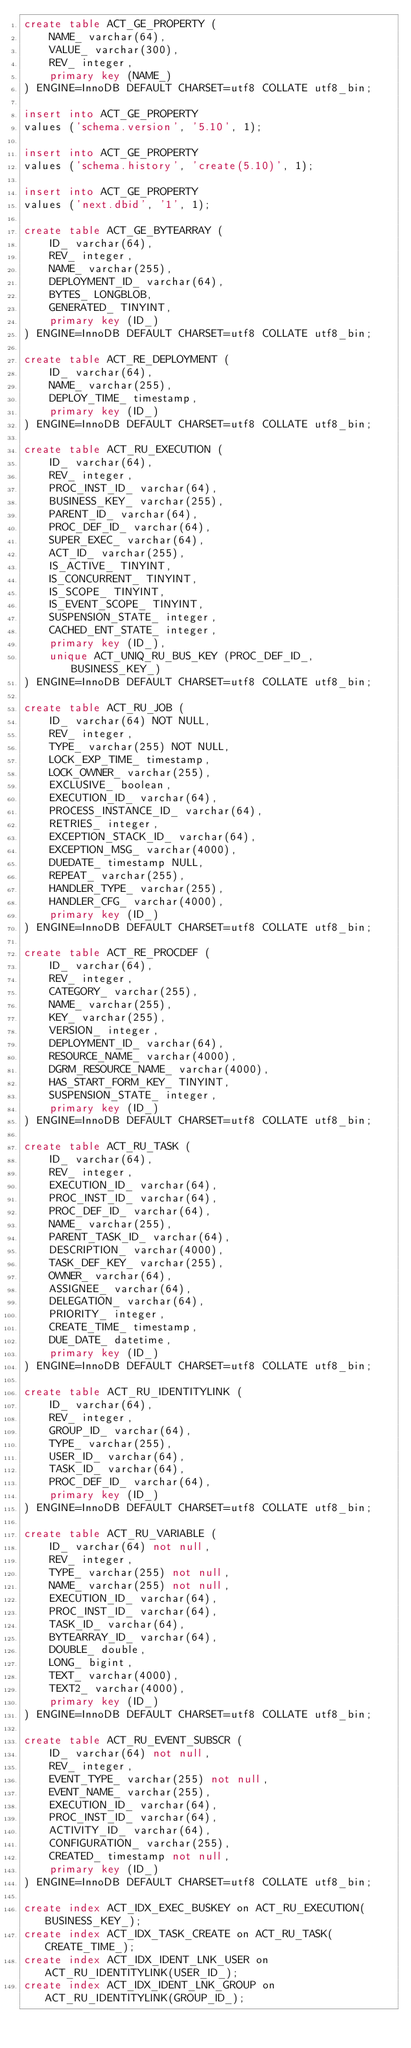Convert code to text. <code><loc_0><loc_0><loc_500><loc_500><_SQL_>create table ACT_GE_PROPERTY (
    NAME_ varchar(64),
    VALUE_ varchar(300),
    REV_ integer,
    primary key (NAME_)
) ENGINE=InnoDB DEFAULT CHARSET=utf8 COLLATE utf8_bin;

insert into ACT_GE_PROPERTY
values ('schema.version', '5.10', 1);

insert into ACT_GE_PROPERTY
values ('schema.history', 'create(5.10)', 1);

insert into ACT_GE_PROPERTY
values ('next.dbid', '1', 1);

create table ACT_GE_BYTEARRAY (
    ID_ varchar(64),
    REV_ integer,
    NAME_ varchar(255),
    DEPLOYMENT_ID_ varchar(64),
    BYTES_ LONGBLOB,
    GENERATED_ TINYINT,
    primary key (ID_)
) ENGINE=InnoDB DEFAULT CHARSET=utf8 COLLATE utf8_bin;

create table ACT_RE_DEPLOYMENT (
    ID_ varchar(64),
    NAME_ varchar(255),
    DEPLOY_TIME_ timestamp,
    primary key (ID_)
) ENGINE=InnoDB DEFAULT CHARSET=utf8 COLLATE utf8_bin;

create table ACT_RU_EXECUTION (
    ID_ varchar(64),
    REV_ integer,
    PROC_INST_ID_ varchar(64),
    BUSINESS_KEY_ varchar(255),
    PARENT_ID_ varchar(64),
    PROC_DEF_ID_ varchar(64),
    SUPER_EXEC_ varchar(64),
    ACT_ID_ varchar(255),
    IS_ACTIVE_ TINYINT,
    IS_CONCURRENT_ TINYINT,
    IS_SCOPE_ TINYINT,
    IS_EVENT_SCOPE_ TINYINT,
    SUSPENSION_STATE_ integer,
    CACHED_ENT_STATE_ integer,
    primary key (ID_),
    unique ACT_UNIQ_RU_BUS_KEY (PROC_DEF_ID_, BUSINESS_KEY_)
) ENGINE=InnoDB DEFAULT CHARSET=utf8 COLLATE utf8_bin;

create table ACT_RU_JOB (
    ID_ varchar(64) NOT NULL,
	  REV_ integer,
    TYPE_ varchar(255) NOT NULL,
    LOCK_EXP_TIME_ timestamp,
    LOCK_OWNER_ varchar(255),
    EXCLUSIVE_ boolean,
    EXECUTION_ID_ varchar(64),
    PROCESS_INSTANCE_ID_ varchar(64),
    RETRIES_ integer,
    EXCEPTION_STACK_ID_ varchar(64),
    EXCEPTION_MSG_ varchar(4000),
    DUEDATE_ timestamp NULL,
    REPEAT_ varchar(255),
    HANDLER_TYPE_ varchar(255),
    HANDLER_CFG_ varchar(4000),
    primary key (ID_)
) ENGINE=InnoDB DEFAULT CHARSET=utf8 COLLATE utf8_bin;

create table ACT_RE_PROCDEF (
    ID_ varchar(64),
    REV_ integer,
    CATEGORY_ varchar(255),
    NAME_ varchar(255),
    KEY_ varchar(255),
    VERSION_ integer,
    DEPLOYMENT_ID_ varchar(64),
    RESOURCE_NAME_ varchar(4000),
    DGRM_RESOURCE_NAME_ varchar(4000),
    HAS_START_FORM_KEY_ TINYINT,
    SUSPENSION_STATE_ integer,
    primary key (ID_)
) ENGINE=InnoDB DEFAULT CHARSET=utf8 COLLATE utf8_bin;

create table ACT_RU_TASK (
    ID_ varchar(64),
    REV_ integer,
    EXECUTION_ID_ varchar(64),
    PROC_INST_ID_ varchar(64),
    PROC_DEF_ID_ varchar(64),
    NAME_ varchar(255),
    PARENT_TASK_ID_ varchar(64),
    DESCRIPTION_ varchar(4000),
    TASK_DEF_KEY_ varchar(255),
    OWNER_ varchar(64),
    ASSIGNEE_ varchar(64),
    DELEGATION_ varchar(64),
    PRIORITY_ integer,
    CREATE_TIME_ timestamp,
    DUE_DATE_ datetime,
    primary key (ID_)
) ENGINE=InnoDB DEFAULT CHARSET=utf8 COLLATE utf8_bin;

create table ACT_RU_IDENTITYLINK (
    ID_ varchar(64),
    REV_ integer,
    GROUP_ID_ varchar(64),
    TYPE_ varchar(255),
    USER_ID_ varchar(64),
    TASK_ID_ varchar(64),
    PROC_DEF_ID_ varchar(64),    
    primary key (ID_)
) ENGINE=InnoDB DEFAULT CHARSET=utf8 COLLATE utf8_bin;

create table ACT_RU_VARIABLE (
    ID_ varchar(64) not null,
    REV_ integer,
    TYPE_ varchar(255) not null,
    NAME_ varchar(255) not null,
    EXECUTION_ID_ varchar(64),
	  PROC_INST_ID_ varchar(64),
    TASK_ID_ varchar(64),
    BYTEARRAY_ID_ varchar(64),
    DOUBLE_ double,
    LONG_ bigint,
    TEXT_ varchar(4000),
    TEXT2_ varchar(4000),
    primary key (ID_)
) ENGINE=InnoDB DEFAULT CHARSET=utf8 COLLATE utf8_bin;

create table ACT_RU_EVENT_SUBSCR (
    ID_ varchar(64) not null,
    REV_ integer,
    EVENT_TYPE_ varchar(255) not null,
    EVENT_NAME_ varchar(255),
    EXECUTION_ID_ varchar(64),
    PROC_INST_ID_ varchar(64),
    ACTIVITY_ID_ varchar(64),
    CONFIGURATION_ varchar(255),
    CREATED_ timestamp not null,
    primary key (ID_)
) ENGINE=InnoDB DEFAULT CHARSET=utf8 COLLATE utf8_bin;

create index ACT_IDX_EXEC_BUSKEY on ACT_RU_EXECUTION(BUSINESS_KEY_);
create index ACT_IDX_TASK_CREATE on ACT_RU_TASK(CREATE_TIME_);
create index ACT_IDX_IDENT_LNK_USER on ACT_RU_IDENTITYLINK(USER_ID_);
create index ACT_IDX_IDENT_LNK_GROUP on ACT_RU_IDENTITYLINK(GROUP_ID_);</code> 